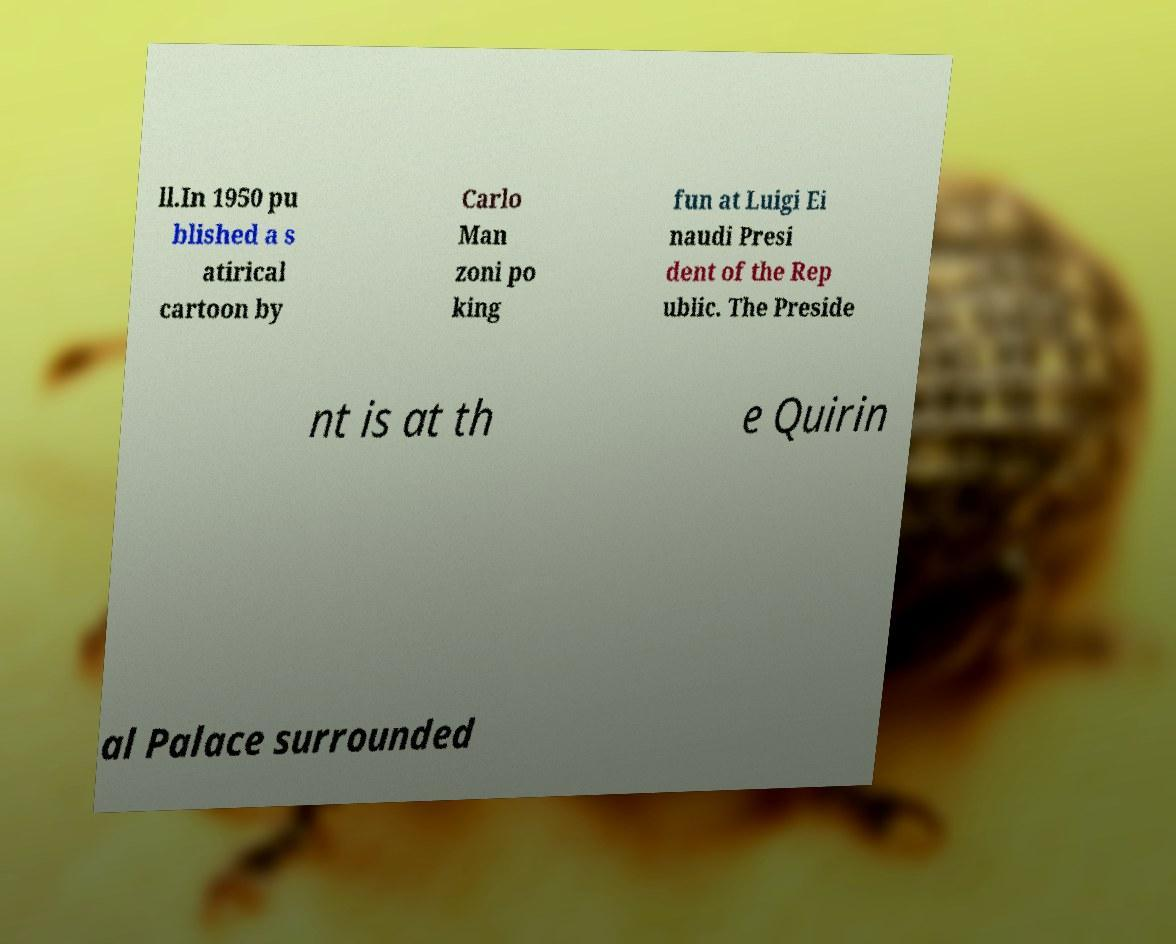I need the written content from this picture converted into text. Can you do that? ll.In 1950 pu blished a s atirical cartoon by Carlo Man zoni po king fun at Luigi Ei naudi Presi dent of the Rep ublic. The Preside nt is at th e Quirin al Palace surrounded 